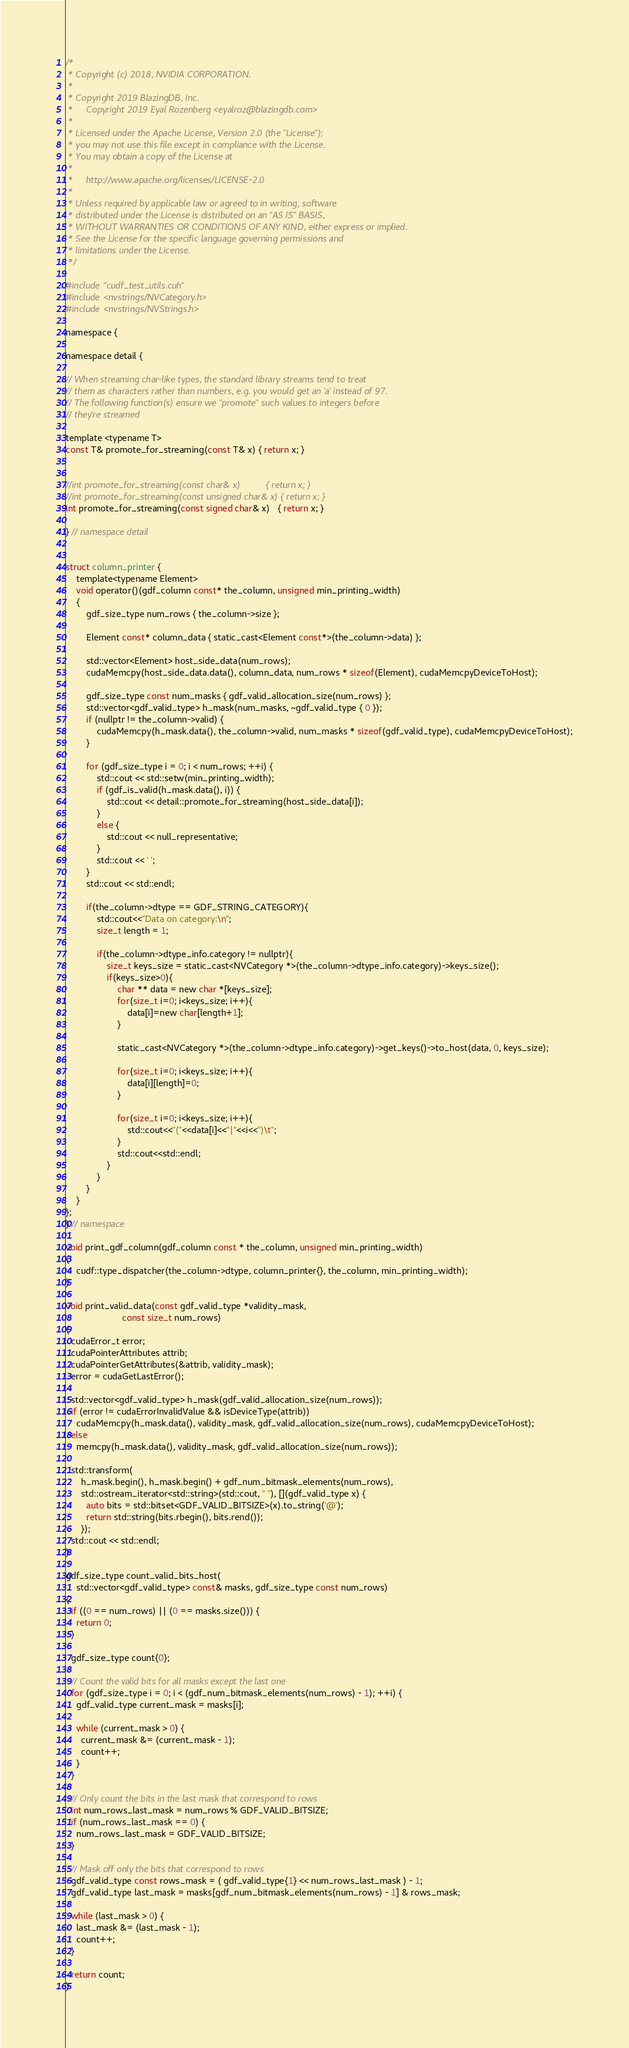Convert code to text. <code><loc_0><loc_0><loc_500><loc_500><_Cuda_>/*
 * Copyright (c) 2018, NVIDIA CORPORATION.
 *
 * Copyright 2019 BlazingDB, Inc.
 *     Copyright 2019 Eyal Rozenberg <eyalroz@blazingdb.com>
 *
 * Licensed under the Apache License, Version 2.0 (the "License");
 * you may not use this file except in compliance with the License.
 * You may obtain a copy of the License at
 *
 *     http://www.apache.org/licenses/LICENSE-2.0
 *
 * Unless required by applicable law or agreed to in writing, software
 * distributed under the License is distributed on an "AS IS" BASIS,
 * WITHOUT WARRANTIES OR CONDITIONS OF ANY KIND, either express or implied.
 * See the License for the specific language governing permissions and
 * limitations under the License.
 */

#include "cudf_test_utils.cuh"
#include <nvstrings/NVCategory.h>
#include <nvstrings/NVStrings.h>

namespace {

namespace detail {

// When streaming char-like types, the standard library streams tend to treat
// them as characters rather than numbers, e.g. you would get an 'a' instead of 97.
// The following function(s) ensure we "promote" such values to integers before
// they're streamed

template <typename T>
const T& promote_for_streaming(const T& x) { return x; }


//int promote_for_streaming(const char& x)          { return x; }
//int promote_for_streaming(const unsigned char& x) { return x; }
int promote_for_streaming(const signed char& x)   { return x; }

} // namespace detail


struct column_printer {
    template<typename Element>
    void operator()(gdf_column const* the_column, unsigned min_printing_width)
    {
        gdf_size_type num_rows { the_column->size };

        Element const* column_data { static_cast<Element const*>(the_column->data) };

        std::vector<Element> host_side_data(num_rows);
        cudaMemcpy(host_side_data.data(), column_data, num_rows * sizeof(Element), cudaMemcpyDeviceToHost);

        gdf_size_type const num_masks { gdf_valid_allocation_size(num_rows) };
        std::vector<gdf_valid_type> h_mask(num_masks, ~gdf_valid_type { 0 });
        if (nullptr != the_column->valid) {
            cudaMemcpy(h_mask.data(), the_column->valid, num_masks * sizeof(gdf_valid_type), cudaMemcpyDeviceToHost);
        }

        for (gdf_size_type i = 0; i < num_rows; ++i) {
            std::cout << std::setw(min_printing_width);
            if (gdf_is_valid(h_mask.data(), i)) {
                std::cout << detail::promote_for_streaming(host_side_data[i]);
            }
            else {
                std::cout << null_representative;
            }
            std::cout << ' ';
        }
        std::cout << std::endl;

        if(the_column->dtype == GDF_STRING_CATEGORY){
            std::cout<<"Data on category:\n";
            size_t length = 1;

            if(the_column->dtype_info.category != nullptr){
                size_t keys_size = static_cast<NVCategory *>(the_column->dtype_info.category)->keys_size();
                if(keys_size>0){
                    char ** data = new char *[keys_size];
                    for(size_t i=0; i<keys_size; i++){
                        data[i]=new char[length+1];
                    }

                    static_cast<NVCategory *>(the_column->dtype_info.category)->get_keys()->to_host(data, 0, keys_size);

                    for(size_t i=0; i<keys_size; i++){
                        data[i][length]=0;
                    }

                    for(size_t i=0; i<keys_size; i++){
                        std::cout<<"("<<data[i]<<"|"<<i<<")\t";
                    }
                    std::cout<<std::endl;
                }
            }
        }
    }
};
} // namespace

void print_gdf_column(gdf_column const * the_column, unsigned min_printing_width)
{
    cudf::type_dispatcher(the_column->dtype, column_printer{}, the_column, min_printing_width);
}

void print_valid_data(const gdf_valid_type *validity_mask,
                      const size_t num_rows)
{
  cudaError_t error;
  cudaPointerAttributes attrib;
  cudaPointerGetAttributes(&attrib, validity_mask);
  error = cudaGetLastError();

  std::vector<gdf_valid_type> h_mask(gdf_valid_allocation_size(num_rows));
  if (error != cudaErrorInvalidValue && isDeviceType(attrib))
    cudaMemcpy(h_mask.data(), validity_mask, gdf_valid_allocation_size(num_rows), cudaMemcpyDeviceToHost);
  else
    memcpy(h_mask.data(), validity_mask, gdf_valid_allocation_size(num_rows));

  std::transform(
      h_mask.begin(), h_mask.begin() + gdf_num_bitmask_elements(num_rows),
      std::ostream_iterator<std::string>(std::cout, " "), [](gdf_valid_type x) {
        auto bits = std::bitset<GDF_VALID_BITSIZE>(x).to_string('@');
        return std::string(bits.rbegin(), bits.rend());
      });
  std::cout << std::endl;
}

gdf_size_type count_valid_bits_host(
    std::vector<gdf_valid_type> const& masks, gdf_size_type const num_rows)
{
  if ((0 == num_rows) || (0 == masks.size())) {
    return 0;
  }

  gdf_size_type count{0};

  // Count the valid bits for all masks except the last one
  for (gdf_size_type i = 0; i < (gdf_num_bitmask_elements(num_rows) - 1); ++i) {
    gdf_valid_type current_mask = masks[i];

    while (current_mask > 0) {
      current_mask &= (current_mask - 1);
      count++;
    }
  }

  // Only count the bits in the last mask that correspond to rows
  int num_rows_last_mask = num_rows % GDF_VALID_BITSIZE;
  if (num_rows_last_mask == 0) {
    num_rows_last_mask = GDF_VALID_BITSIZE;
  }

  // Mask off only the bits that correspond to rows
  gdf_valid_type const rows_mask = ( gdf_valid_type{1} << num_rows_last_mask ) - 1;
  gdf_valid_type last_mask = masks[gdf_num_bitmask_elements(num_rows) - 1] & rows_mask;

  while (last_mask > 0) {
    last_mask &= (last_mask - 1);
    count++;
  }

  return count;
}
</code> 